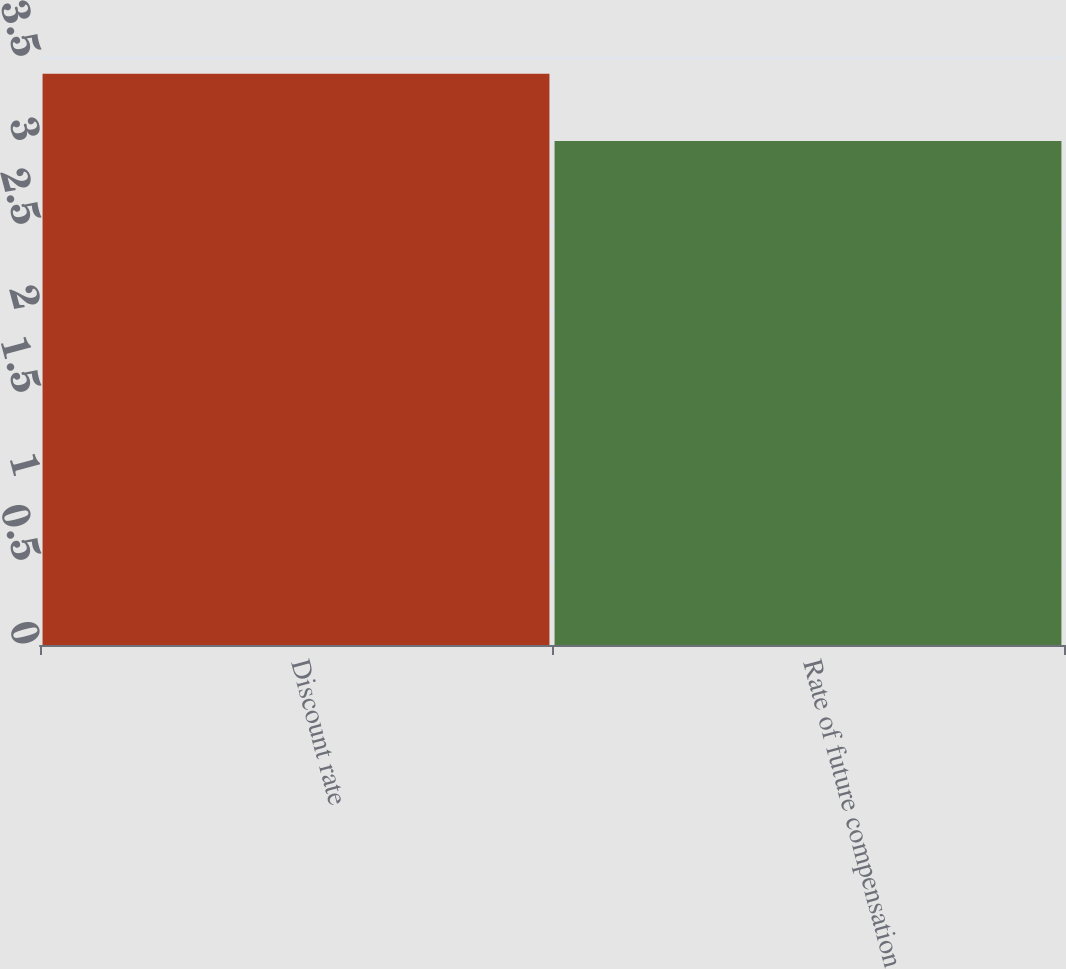Convert chart. <chart><loc_0><loc_0><loc_500><loc_500><bar_chart><fcel>Discount rate<fcel>Rate of future compensation<nl><fcel>3.4<fcel>3<nl></chart> 